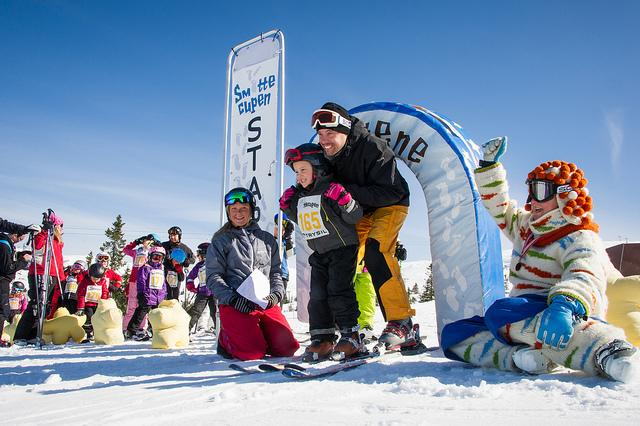Why are the children wearing numbers on their jackets? Please explain your reasoning. for competition. The kids are competing. 